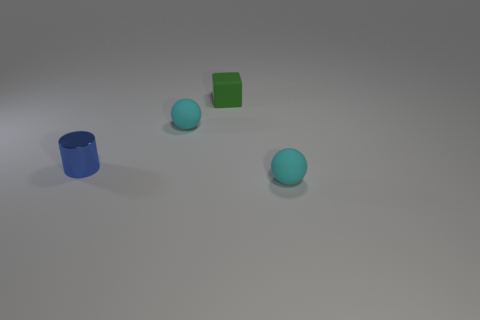Add 4 large cyan blocks. How many objects exist? 8 Subtract all cylinders. How many objects are left? 3 Subtract 0 green cylinders. How many objects are left? 4 Subtract all red spheres. Subtract all gray cubes. How many spheres are left? 2 Subtract all tiny green things. Subtract all big green rubber cylinders. How many objects are left? 3 Add 2 green rubber things. How many green rubber things are left? 3 Add 1 tiny red metal spheres. How many tiny red metal spheres exist? 1 